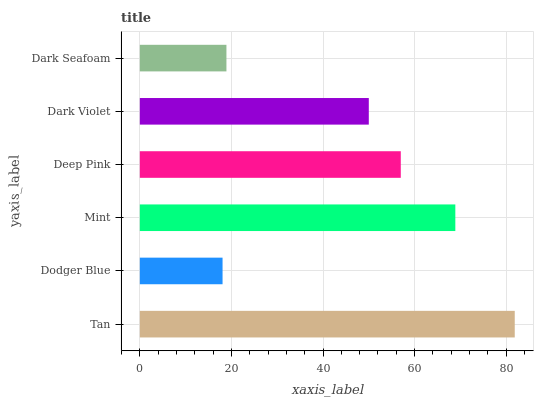Is Dodger Blue the minimum?
Answer yes or no. Yes. Is Tan the maximum?
Answer yes or no. Yes. Is Mint the minimum?
Answer yes or no. No. Is Mint the maximum?
Answer yes or no. No. Is Mint greater than Dodger Blue?
Answer yes or no. Yes. Is Dodger Blue less than Mint?
Answer yes or no. Yes. Is Dodger Blue greater than Mint?
Answer yes or no. No. Is Mint less than Dodger Blue?
Answer yes or no. No. Is Deep Pink the high median?
Answer yes or no. Yes. Is Dark Violet the low median?
Answer yes or no. Yes. Is Tan the high median?
Answer yes or no. No. Is Dark Seafoam the low median?
Answer yes or no. No. 